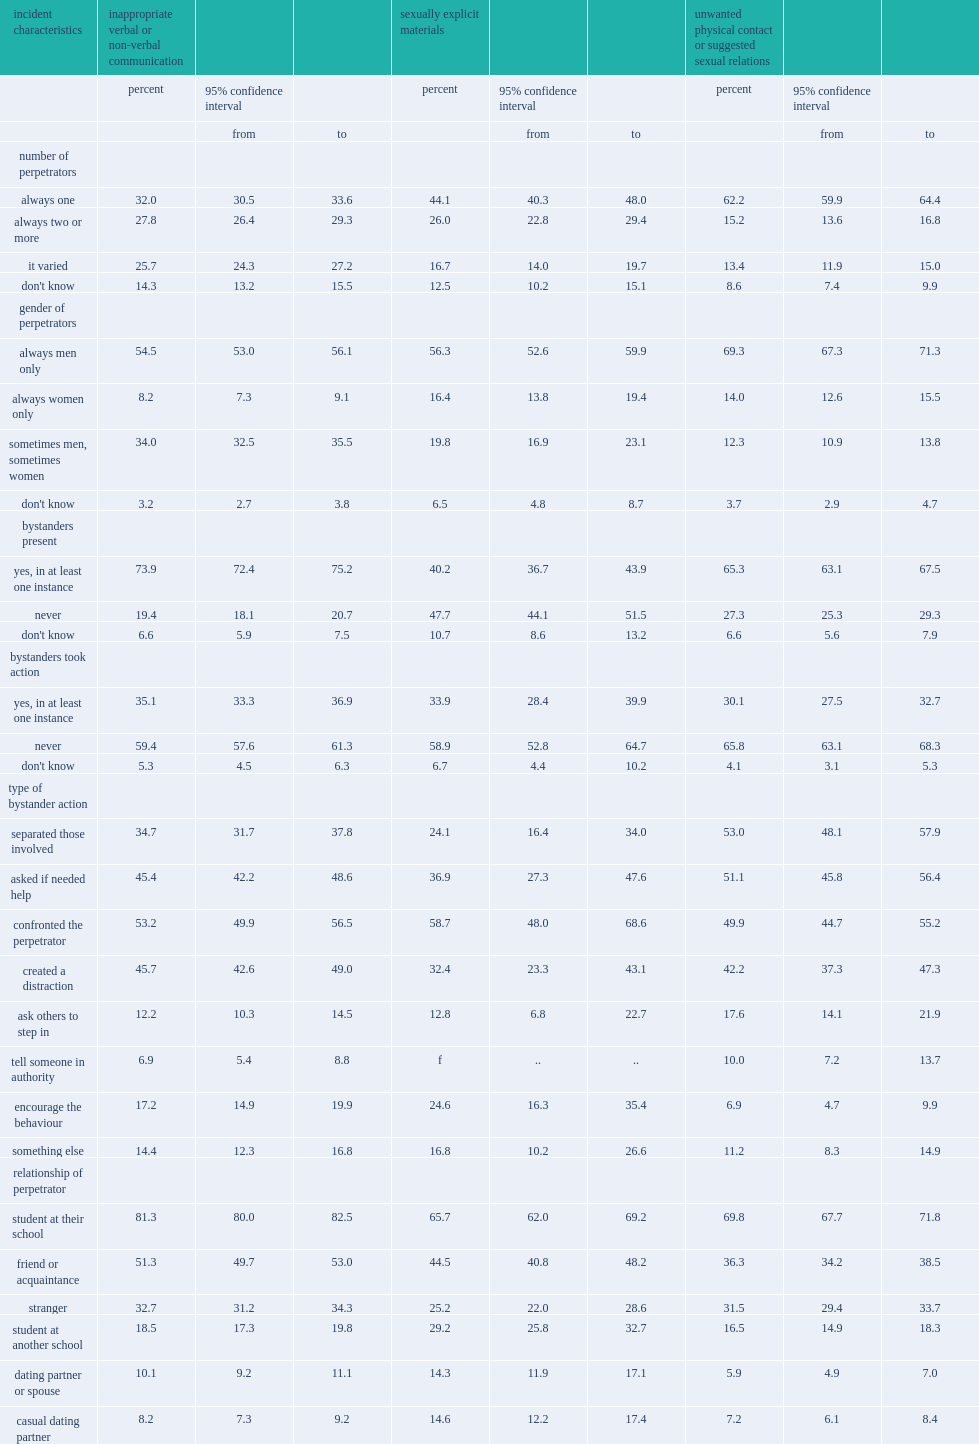How many percent of those who experienced inappropriate communication? 73.9. How many percent of those who experienced physical contact or suggested sexual relations said that was the case? 65.3. 